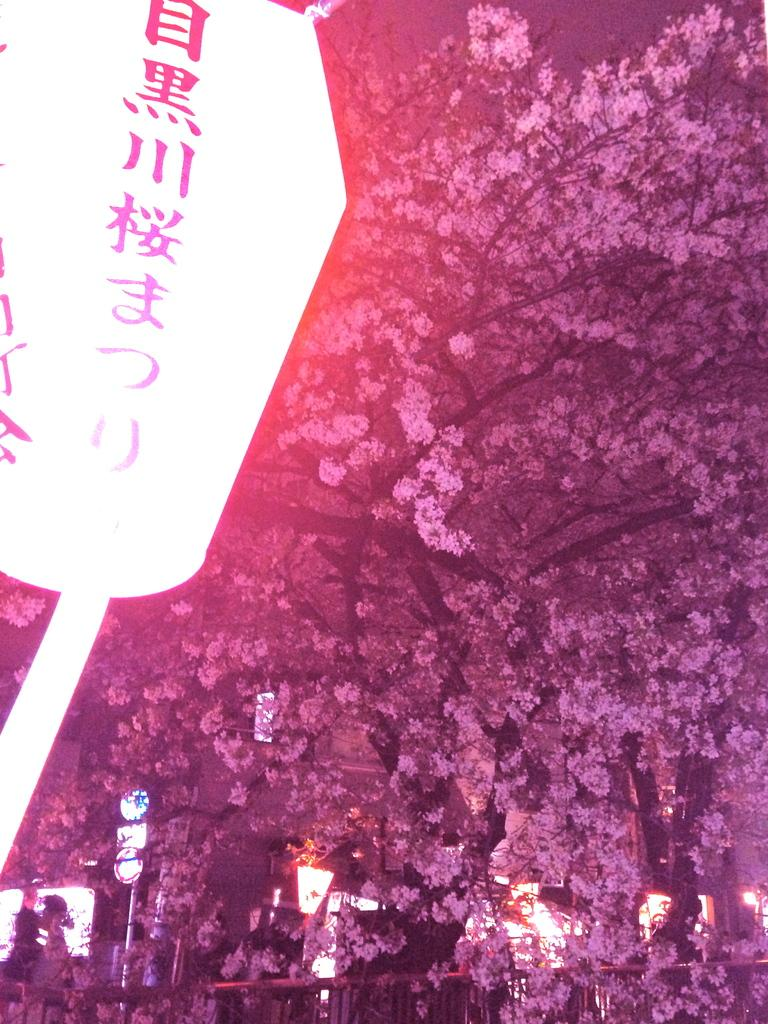What type of natural elements can be seen in the image? There are trees in the image. What artificial elements can be seen in the image? There are lights in the image. Can you describe an object with text or symbols in the image? There is an object with writing on it in the image. Can you describe the behavior of the birds in the nest in the image? There is no nest or birds present in the image. 